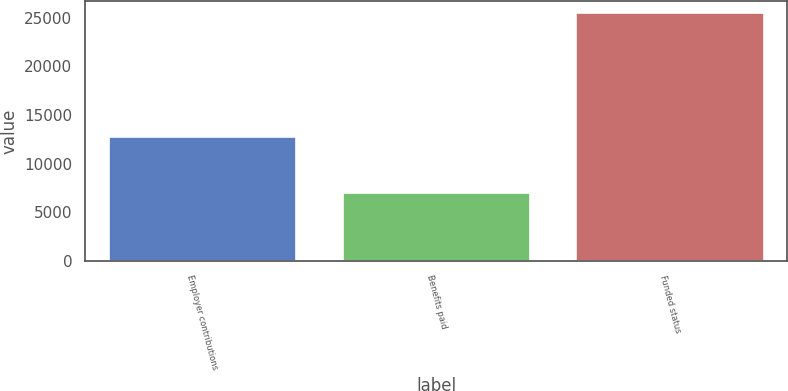Convert chart. <chart><loc_0><loc_0><loc_500><loc_500><bar_chart><fcel>Employer contributions<fcel>Benefits paid<fcel>Funded status<nl><fcel>12757<fcel>7020<fcel>25441<nl></chart> 